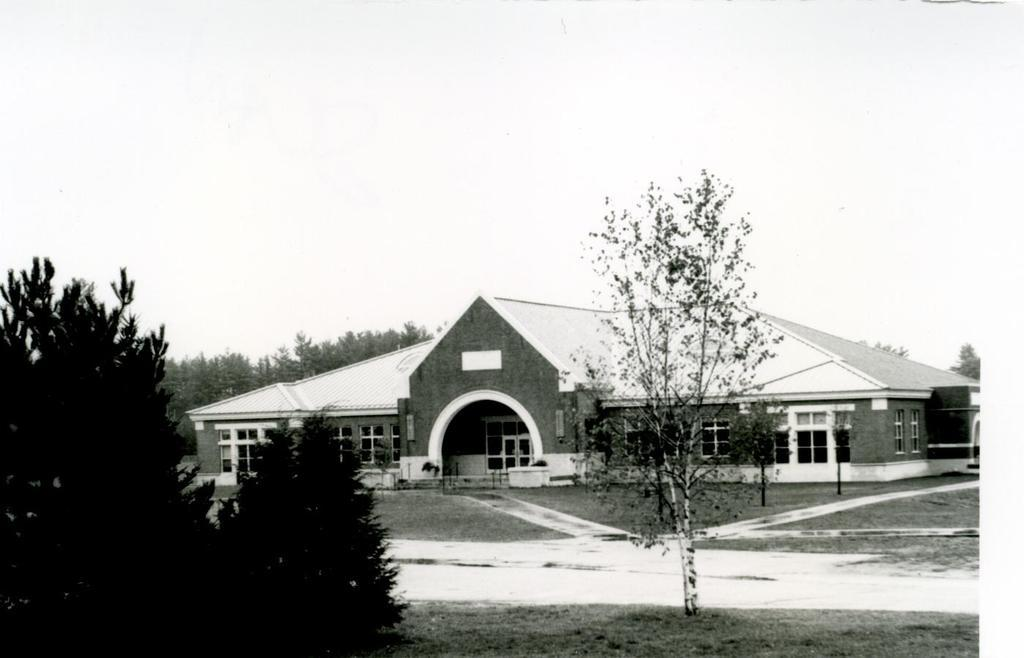What type of structure is in the picture? There is a building in the picture. What features can be seen on the building? The building has windows and doors. What is located on the left side of the picture? There are trees on the left side of the picture. What is the condition of the ground in the picture? The ground has snow on it. What is the condition of the sky in the picture? The sky is clear in the picture. What type of disgust can be seen in the image? There is no disgust present in the image. 